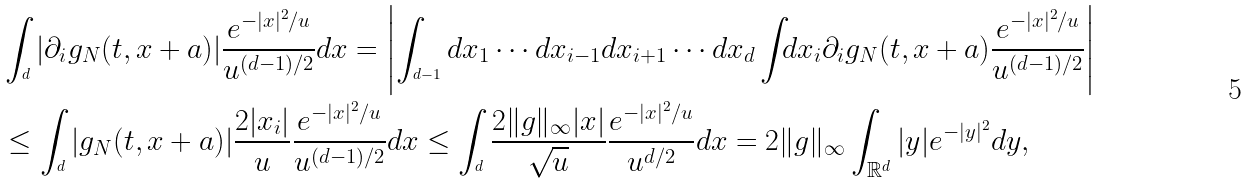Convert formula to latex. <formula><loc_0><loc_0><loc_500><loc_500>& \int _ { \real ^ { d } } | \partial _ { i } g _ { N } ( t , x + a ) | \frac { e ^ { - | x | ^ { 2 } / u } } { u ^ { ( d - 1 ) / 2 } } d x = \left | \int _ { \real ^ { d - 1 } } d x _ { 1 } \cdots d x _ { i - 1 } d x _ { i + 1 } \cdots d x _ { d } \int _ { \real } d x _ { i } \partial _ { i } g _ { N } ( t , x + a ) \frac { e ^ { - | x | ^ { 2 } / u } } { u ^ { ( d - 1 ) / 2 } } \right | \\ & \leq \int _ { \real ^ { d } } | g _ { N } ( t , x + a ) | \frac { 2 | x _ { i } | } { u } \frac { e ^ { - | x | ^ { 2 } / u } } { u ^ { ( d - 1 ) / 2 } } d x \leq \int _ { \real ^ { d } } \frac { 2 \| g \| _ { \infty } | x | } { \sqrt { u } } \frac { e ^ { - | x | ^ { 2 } / u } } { u ^ { d / 2 } } d x = 2 \| g \| _ { \infty } \int _ { \mathbb { R } ^ { d } } | y | e ^ { - | y | ^ { 2 } } d y ,</formula> 